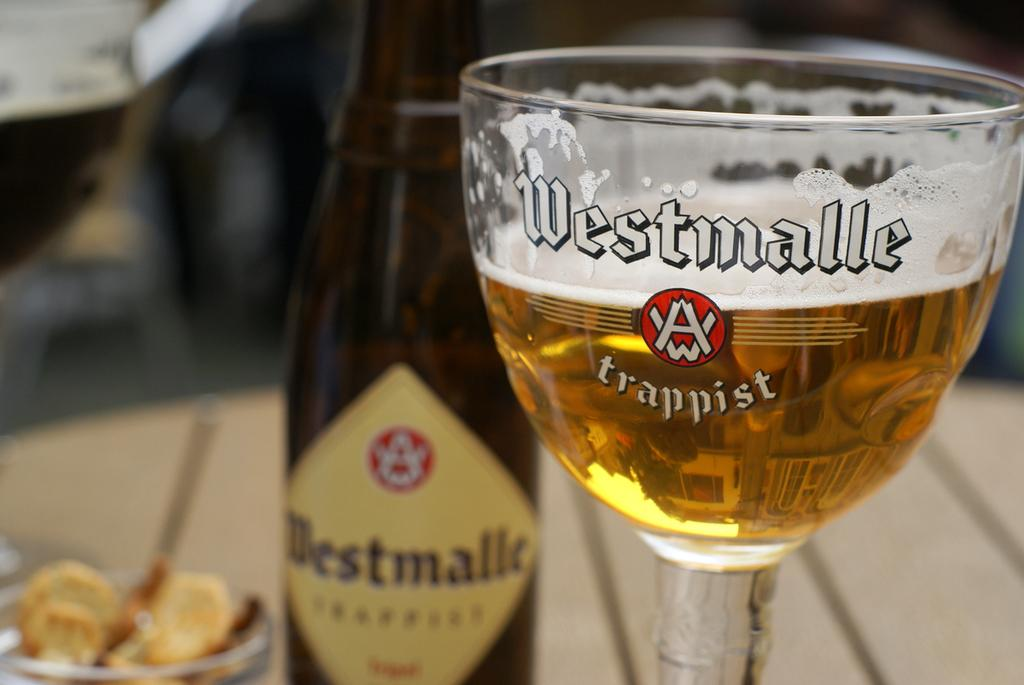<image>
Present a compact description of the photo's key features. A bottle of Westmalle beer and a tall glass beside it. 